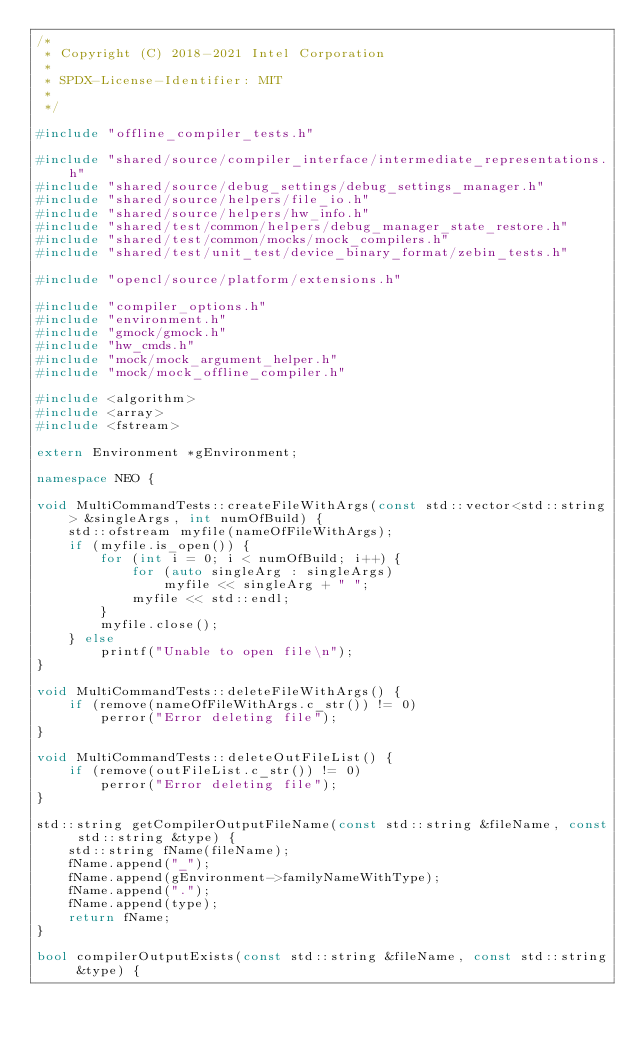<code> <loc_0><loc_0><loc_500><loc_500><_C++_>/*
 * Copyright (C) 2018-2021 Intel Corporation
 *
 * SPDX-License-Identifier: MIT
 *
 */

#include "offline_compiler_tests.h"

#include "shared/source/compiler_interface/intermediate_representations.h"
#include "shared/source/debug_settings/debug_settings_manager.h"
#include "shared/source/helpers/file_io.h"
#include "shared/source/helpers/hw_info.h"
#include "shared/test/common/helpers/debug_manager_state_restore.h"
#include "shared/test/common/mocks/mock_compilers.h"
#include "shared/test/unit_test/device_binary_format/zebin_tests.h"

#include "opencl/source/platform/extensions.h"

#include "compiler_options.h"
#include "environment.h"
#include "gmock/gmock.h"
#include "hw_cmds.h"
#include "mock/mock_argument_helper.h"
#include "mock/mock_offline_compiler.h"

#include <algorithm>
#include <array>
#include <fstream>

extern Environment *gEnvironment;

namespace NEO {

void MultiCommandTests::createFileWithArgs(const std::vector<std::string> &singleArgs, int numOfBuild) {
    std::ofstream myfile(nameOfFileWithArgs);
    if (myfile.is_open()) {
        for (int i = 0; i < numOfBuild; i++) {
            for (auto singleArg : singleArgs)
                myfile << singleArg + " ";
            myfile << std::endl;
        }
        myfile.close();
    } else
        printf("Unable to open file\n");
}

void MultiCommandTests::deleteFileWithArgs() {
    if (remove(nameOfFileWithArgs.c_str()) != 0)
        perror("Error deleting file");
}

void MultiCommandTests::deleteOutFileList() {
    if (remove(outFileList.c_str()) != 0)
        perror("Error deleting file");
}

std::string getCompilerOutputFileName(const std::string &fileName, const std::string &type) {
    std::string fName(fileName);
    fName.append("_");
    fName.append(gEnvironment->familyNameWithType);
    fName.append(".");
    fName.append(type);
    return fName;
}

bool compilerOutputExists(const std::string &fileName, const std::string &type) {</code> 